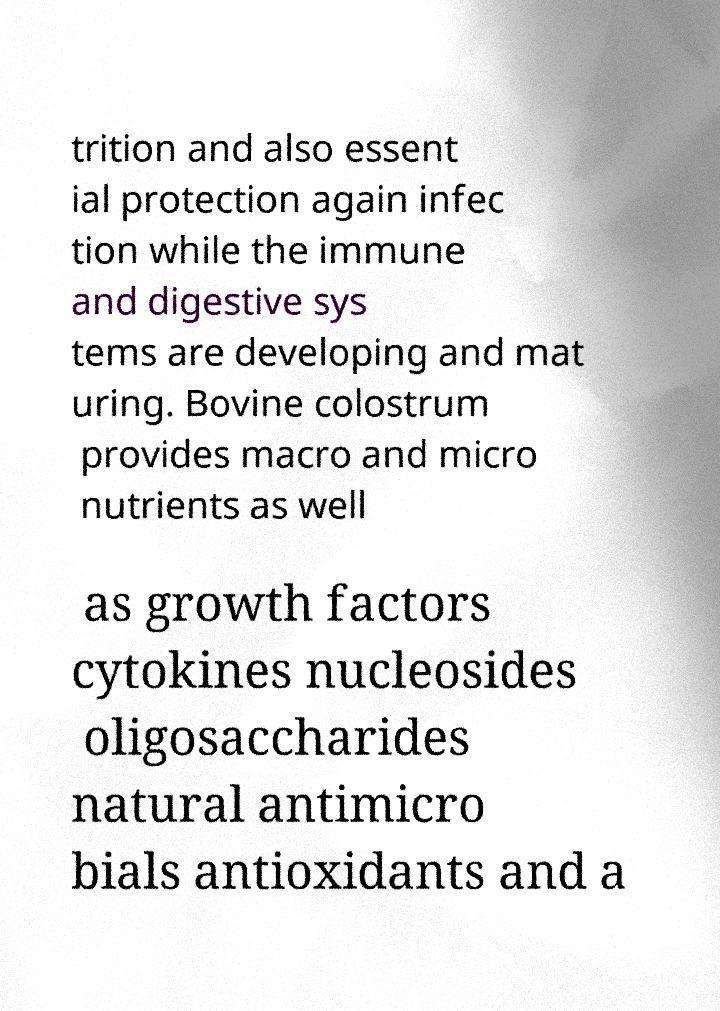Could you assist in decoding the text presented in this image and type it out clearly? trition and also essent ial protection again infec tion while the immune and digestive sys tems are developing and mat uring. Bovine colostrum provides macro and micro nutrients as well as growth factors cytokines nucleosides oligosaccharides natural antimicro bials antioxidants and a 